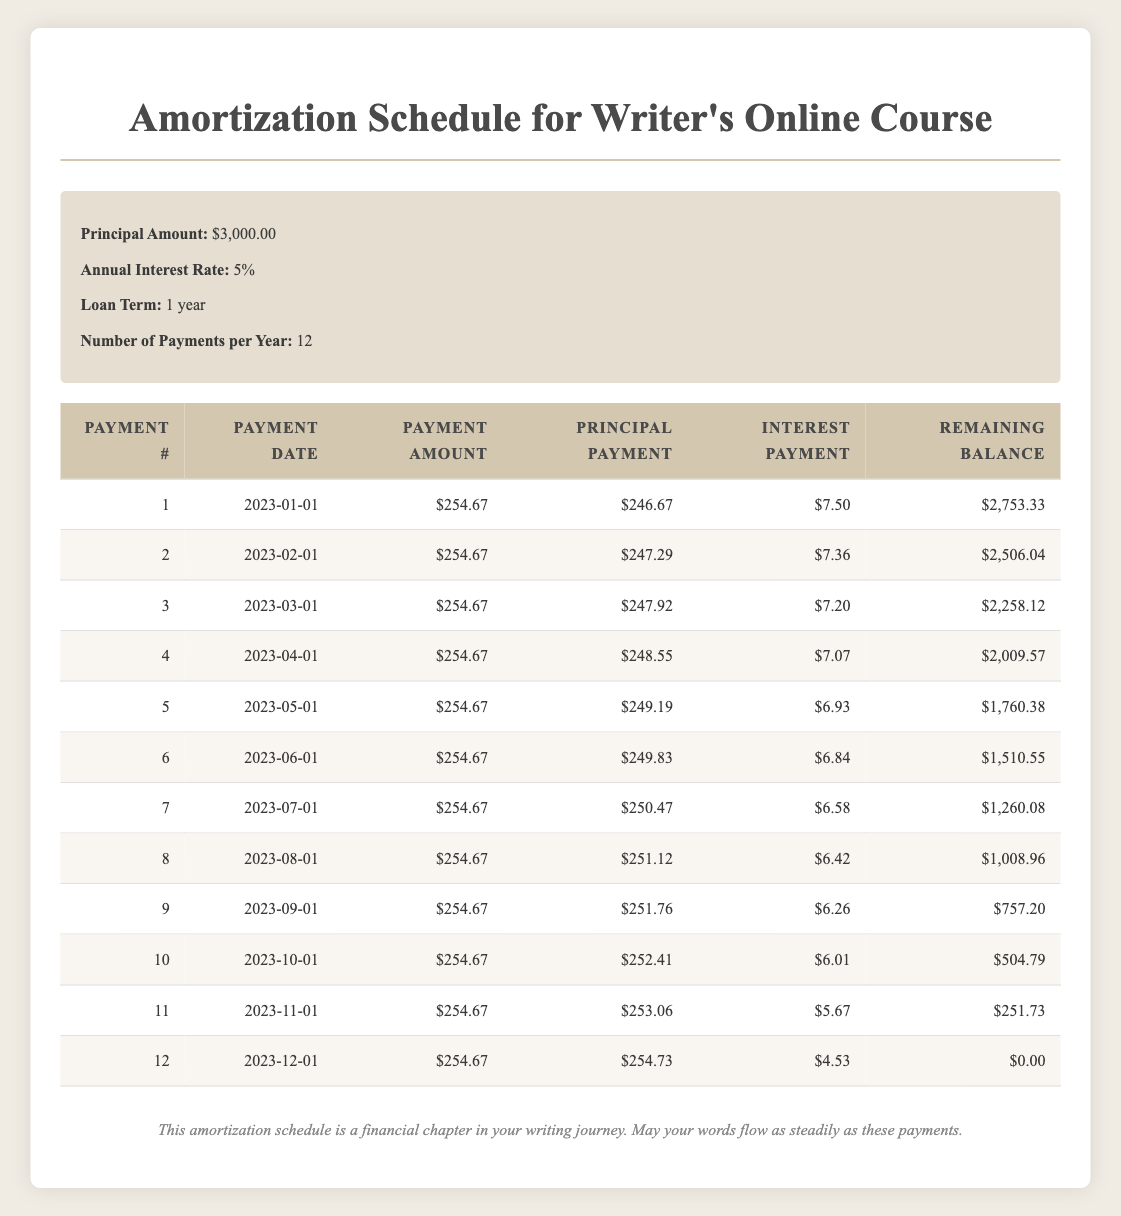What is the total amount paid over the life of the loan? The total amount paid is calculated by multiplying the monthly payment amount by the total number of payments. There are 12 payments of $254.67 each, so the total is 12 * 254.67 = $3,036.04.
Answer: $3,036.04 What was the principal payment in the final month? According to the table, the principal payment for the 12th month is listed as $254.73.
Answer: $254.73 How much interest was paid in the first month? The table shows that the interest payment for the first month is $7.50.
Answer: $7.50 Is the remaining balance after the 6th payment less than $1,500? Looking at the table, the remaining balance after the 6th payment is $1,510.55, which is greater than $1,500.
Answer: No What is the average principal payment over the entire year? To find the average principal payment, we sum the principal payments from all 12 months: 246.67 + 247.29 + 247.92 + 248.55 + 249.19 + 249.83 + 250.47 + 251.12 + 251.76 + 252.41 + 253.06 + 254.73 = 3,025.51. Then divide by 12 to find the average: 3,025.51 / 12 ≈ 252.13.
Answer: $252.13 What was the total interest paid over the year? The total interest paid is calculated by summing the interest payments from all 12 months: 7.50 + 7.36 + 7.20 + 7.07 + 6.93 + 6.84 + 6.58 + 6.42 + 6.26 + 6.01 + 5.67 + 4.53 = 68.65.
Answer: $68.65 How many payments had a principal payment of over $250? By examining the principal payments in the table, payments with principal payments over $250 are: 250.47, 251.12, 251.76, 252.41, 253.06, and 254.73. This gives us a total of 6 payments.
Answer: 6 What is the interest payment in the 6th month compared to the first month? The interest payment in the 6th month is $6.84, and in the first month it is $7.50. Comparing these, $6.84 is less than $7.50 by $0.66.
Answer: $0.66 less Is the total principal paid in the first half of the year greater than the total principal in the second half? Calculating the total principal paid in the first half (months 1-6): 246.67 + 247.29 + 247.92 + 248.55 + 249.19 + 249.83 = 1,489.45. For the second half (months 7-12): 250.47 + 251.12 + 251.76 + 252.41 + 253.06 + 254.73 = 1,511.55. Since 1,489.45 < 1,511.55, the total principal paid in the first half is not greater.
Answer: No 